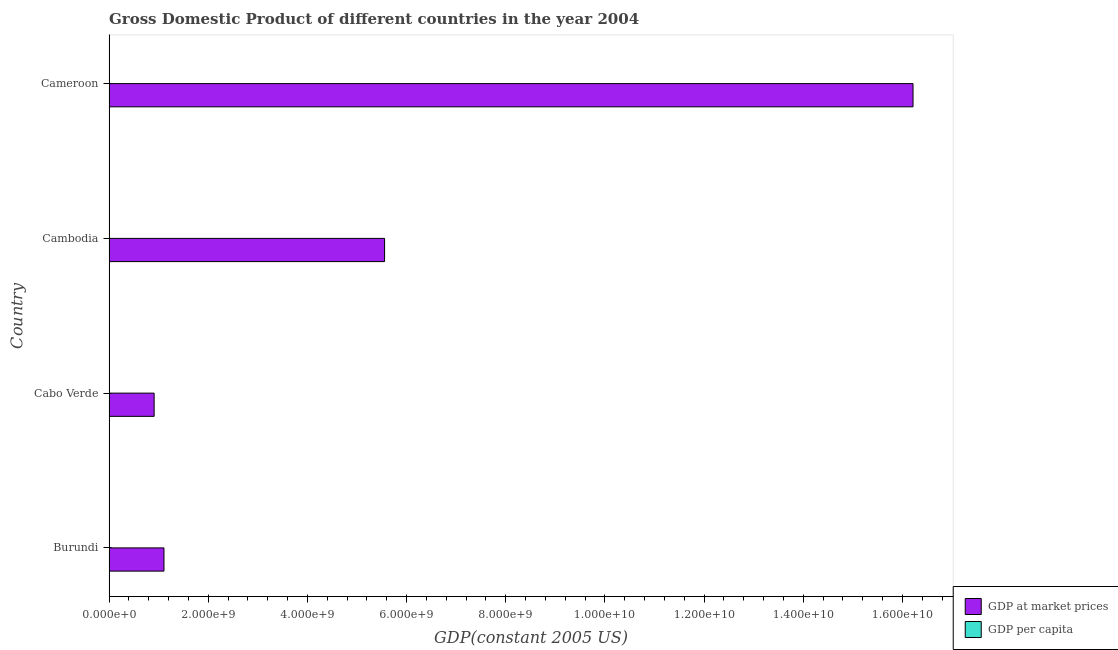How many groups of bars are there?
Your answer should be compact. 4. How many bars are there on the 4th tick from the top?
Your answer should be compact. 2. How many bars are there on the 4th tick from the bottom?
Offer a terse response. 2. What is the label of the 1st group of bars from the top?
Keep it short and to the point. Cameroon. What is the gdp per capita in Burundi?
Provide a short and direct response. 144.52. Across all countries, what is the maximum gdp per capita?
Provide a short and direct response. 1938.51. Across all countries, what is the minimum gdp at market prices?
Provide a short and direct response. 9.09e+08. In which country was the gdp per capita maximum?
Ensure brevity in your answer.  Cabo Verde. In which country was the gdp per capita minimum?
Make the answer very short. Burundi. What is the total gdp at market prices in the graph?
Provide a short and direct response. 2.38e+1. What is the difference between the gdp per capita in Burundi and that in Cameroon?
Your response must be concise. -773.28. What is the difference between the gdp at market prices in Burundi and the gdp per capita in Cameroon?
Offer a terse response. 1.11e+09. What is the average gdp at market prices per country?
Your answer should be compact. 5.95e+09. What is the difference between the gdp at market prices and gdp per capita in Burundi?
Your answer should be compact. 1.11e+09. In how many countries, is the gdp per capita greater than 13200000000 US$?
Ensure brevity in your answer.  0. What is the ratio of the gdp per capita in Burundi to that in Cameroon?
Your answer should be compact. 0.16. What is the difference between the highest and the second highest gdp per capita?
Make the answer very short. 1020.71. What is the difference between the highest and the lowest gdp per capita?
Your answer should be very brief. 1793.99. Is the sum of the gdp at market prices in Cabo Verde and Cameroon greater than the maximum gdp per capita across all countries?
Provide a short and direct response. Yes. What does the 1st bar from the top in Burundi represents?
Ensure brevity in your answer.  GDP per capita. What does the 2nd bar from the bottom in Cabo Verde represents?
Ensure brevity in your answer.  GDP per capita. How many bars are there?
Offer a terse response. 8. Are all the bars in the graph horizontal?
Your response must be concise. Yes. How many countries are there in the graph?
Your answer should be compact. 4. What is the difference between two consecutive major ticks on the X-axis?
Give a very brief answer. 2.00e+09. Does the graph contain any zero values?
Your response must be concise. No. Where does the legend appear in the graph?
Give a very brief answer. Bottom right. How many legend labels are there?
Ensure brevity in your answer.  2. What is the title of the graph?
Make the answer very short. Gross Domestic Product of different countries in the year 2004. What is the label or title of the X-axis?
Give a very brief answer. GDP(constant 2005 US). What is the label or title of the Y-axis?
Keep it short and to the point. Country. What is the GDP(constant 2005 US) in GDP at market prices in Burundi?
Give a very brief answer. 1.11e+09. What is the GDP(constant 2005 US) in GDP per capita in Burundi?
Make the answer very short. 144.52. What is the GDP(constant 2005 US) in GDP at market prices in Cabo Verde?
Keep it short and to the point. 9.09e+08. What is the GDP(constant 2005 US) in GDP per capita in Cabo Verde?
Your answer should be compact. 1938.51. What is the GDP(constant 2005 US) of GDP at market prices in Cambodia?
Make the answer very short. 5.56e+09. What is the GDP(constant 2005 US) in GDP per capita in Cambodia?
Offer a terse response. 423.78. What is the GDP(constant 2005 US) in GDP at market prices in Cameroon?
Offer a terse response. 1.62e+1. What is the GDP(constant 2005 US) of GDP per capita in Cameroon?
Provide a short and direct response. 917.81. Across all countries, what is the maximum GDP(constant 2005 US) in GDP at market prices?
Make the answer very short. 1.62e+1. Across all countries, what is the maximum GDP(constant 2005 US) in GDP per capita?
Your answer should be very brief. 1938.51. Across all countries, what is the minimum GDP(constant 2005 US) of GDP at market prices?
Your answer should be very brief. 9.09e+08. Across all countries, what is the minimum GDP(constant 2005 US) in GDP per capita?
Make the answer very short. 144.52. What is the total GDP(constant 2005 US) of GDP at market prices in the graph?
Make the answer very short. 2.38e+1. What is the total GDP(constant 2005 US) in GDP per capita in the graph?
Make the answer very short. 3424.63. What is the difference between the GDP(constant 2005 US) in GDP at market prices in Burundi and that in Cabo Verde?
Give a very brief answer. 1.98e+08. What is the difference between the GDP(constant 2005 US) in GDP per capita in Burundi and that in Cabo Verde?
Ensure brevity in your answer.  -1793.99. What is the difference between the GDP(constant 2005 US) in GDP at market prices in Burundi and that in Cambodia?
Your response must be concise. -4.45e+09. What is the difference between the GDP(constant 2005 US) of GDP per capita in Burundi and that in Cambodia?
Your response must be concise. -279.26. What is the difference between the GDP(constant 2005 US) in GDP at market prices in Burundi and that in Cameroon?
Offer a terse response. -1.51e+1. What is the difference between the GDP(constant 2005 US) in GDP per capita in Burundi and that in Cameroon?
Offer a terse response. -773.28. What is the difference between the GDP(constant 2005 US) in GDP at market prices in Cabo Verde and that in Cambodia?
Ensure brevity in your answer.  -4.65e+09. What is the difference between the GDP(constant 2005 US) of GDP per capita in Cabo Verde and that in Cambodia?
Your answer should be very brief. 1514.73. What is the difference between the GDP(constant 2005 US) of GDP at market prices in Cabo Verde and that in Cameroon?
Your answer should be very brief. -1.53e+1. What is the difference between the GDP(constant 2005 US) in GDP per capita in Cabo Verde and that in Cameroon?
Make the answer very short. 1020.71. What is the difference between the GDP(constant 2005 US) of GDP at market prices in Cambodia and that in Cameroon?
Your answer should be very brief. -1.07e+1. What is the difference between the GDP(constant 2005 US) of GDP per capita in Cambodia and that in Cameroon?
Provide a succinct answer. -494.02. What is the difference between the GDP(constant 2005 US) in GDP at market prices in Burundi and the GDP(constant 2005 US) in GDP per capita in Cabo Verde?
Keep it short and to the point. 1.11e+09. What is the difference between the GDP(constant 2005 US) in GDP at market prices in Burundi and the GDP(constant 2005 US) in GDP per capita in Cambodia?
Your response must be concise. 1.11e+09. What is the difference between the GDP(constant 2005 US) of GDP at market prices in Burundi and the GDP(constant 2005 US) of GDP per capita in Cameroon?
Provide a succinct answer. 1.11e+09. What is the difference between the GDP(constant 2005 US) of GDP at market prices in Cabo Verde and the GDP(constant 2005 US) of GDP per capita in Cambodia?
Your answer should be compact. 9.09e+08. What is the difference between the GDP(constant 2005 US) in GDP at market prices in Cabo Verde and the GDP(constant 2005 US) in GDP per capita in Cameroon?
Your answer should be compact. 9.09e+08. What is the difference between the GDP(constant 2005 US) of GDP at market prices in Cambodia and the GDP(constant 2005 US) of GDP per capita in Cameroon?
Your answer should be very brief. 5.56e+09. What is the average GDP(constant 2005 US) in GDP at market prices per country?
Provide a short and direct response. 5.95e+09. What is the average GDP(constant 2005 US) of GDP per capita per country?
Provide a short and direct response. 856.16. What is the difference between the GDP(constant 2005 US) in GDP at market prices and GDP(constant 2005 US) in GDP per capita in Burundi?
Offer a very short reply. 1.11e+09. What is the difference between the GDP(constant 2005 US) in GDP at market prices and GDP(constant 2005 US) in GDP per capita in Cabo Verde?
Offer a very short reply. 9.09e+08. What is the difference between the GDP(constant 2005 US) of GDP at market prices and GDP(constant 2005 US) of GDP per capita in Cambodia?
Offer a very short reply. 5.56e+09. What is the difference between the GDP(constant 2005 US) in GDP at market prices and GDP(constant 2005 US) in GDP per capita in Cameroon?
Provide a succinct answer. 1.62e+1. What is the ratio of the GDP(constant 2005 US) of GDP at market prices in Burundi to that in Cabo Verde?
Your answer should be compact. 1.22. What is the ratio of the GDP(constant 2005 US) in GDP per capita in Burundi to that in Cabo Verde?
Offer a very short reply. 0.07. What is the ratio of the GDP(constant 2005 US) in GDP at market prices in Burundi to that in Cambodia?
Make the answer very short. 0.2. What is the ratio of the GDP(constant 2005 US) in GDP per capita in Burundi to that in Cambodia?
Offer a very short reply. 0.34. What is the ratio of the GDP(constant 2005 US) in GDP at market prices in Burundi to that in Cameroon?
Offer a terse response. 0.07. What is the ratio of the GDP(constant 2005 US) in GDP per capita in Burundi to that in Cameroon?
Ensure brevity in your answer.  0.16. What is the ratio of the GDP(constant 2005 US) in GDP at market prices in Cabo Verde to that in Cambodia?
Offer a very short reply. 0.16. What is the ratio of the GDP(constant 2005 US) in GDP per capita in Cabo Verde to that in Cambodia?
Ensure brevity in your answer.  4.57. What is the ratio of the GDP(constant 2005 US) of GDP at market prices in Cabo Verde to that in Cameroon?
Make the answer very short. 0.06. What is the ratio of the GDP(constant 2005 US) in GDP per capita in Cabo Verde to that in Cameroon?
Make the answer very short. 2.11. What is the ratio of the GDP(constant 2005 US) in GDP at market prices in Cambodia to that in Cameroon?
Your response must be concise. 0.34. What is the ratio of the GDP(constant 2005 US) in GDP per capita in Cambodia to that in Cameroon?
Offer a very short reply. 0.46. What is the difference between the highest and the second highest GDP(constant 2005 US) of GDP at market prices?
Give a very brief answer. 1.07e+1. What is the difference between the highest and the second highest GDP(constant 2005 US) of GDP per capita?
Your answer should be very brief. 1020.71. What is the difference between the highest and the lowest GDP(constant 2005 US) of GDP at market prices?
Your answer should be compact. 1.53e+1. What is the difference between the highest and the lowest GDP(constant 2005 US) of GDP per capita?
Offer a very short reply. 1793.99. 